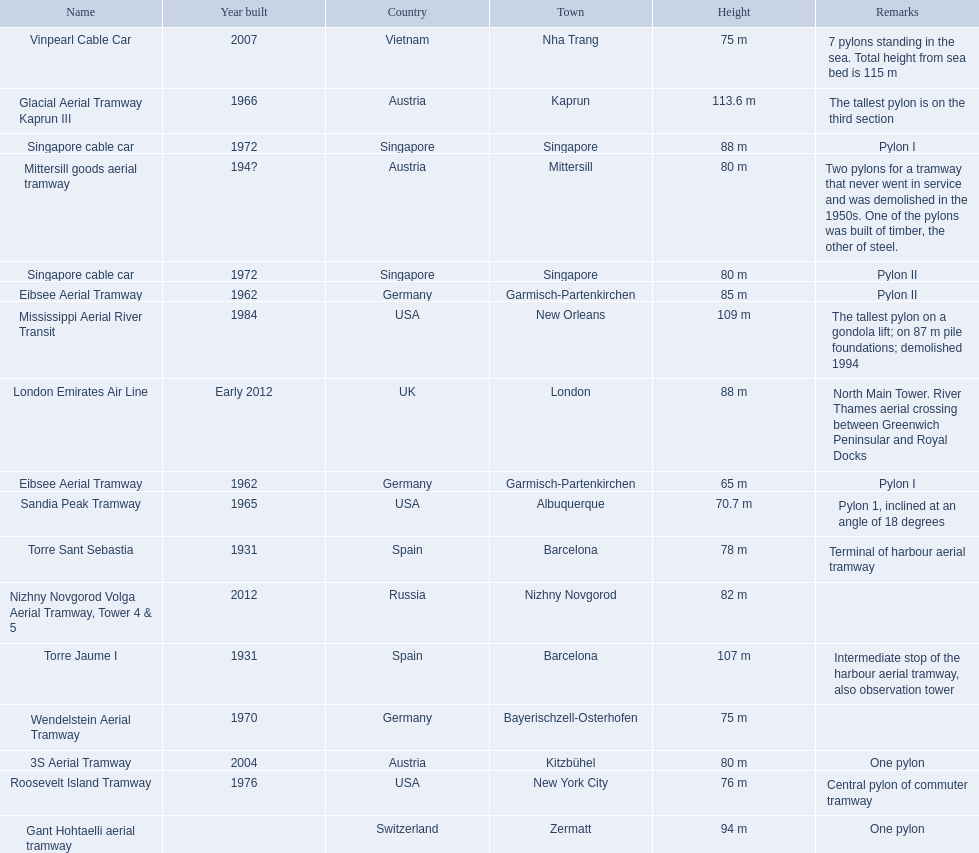Which aerial lifts are over 100 meters tall? Glacial Aerial Tramway Kaprun III, Mississippi Aerial River Transit, Torre Jaume I. Which of those was built last? Mississippi Aerial River Transit. And what is its total height? 109 m. Which lift has the second highest height? Mississippi Aerial River Transit. Can you give me this table as a dict? {'header': ['Name', 'Year built', 'Country', 'Town', 'Height', 'Remarks'], 'rows': [['Vinpearl Cable Car', '2007', 'Vietnam', 'Nha Trang', '75 m', '7 pylons standing in the sea. Total height from sea bed is 115 m'], ['Glacial Aerial Tramway Kaprun III', '1966', 'Austria', 'Kaprun', '113.6 m', 'The tallest pylon is on the third section'], ['Singapore cable car', '1972', 'Singapore', 'Singapore', '88 m', 'Pylon I'], ['Mittersill goods aerial tramway', '194?', 'Austria', 'Mittersill', '80 m', 'Two pylons for a tramway that never went in service and was demolished in the 1950s. One of the pylons was built of timber, the other of steel.'], ['Singapore cable car', '1972', 'Singapore', 'Singapore', '80 m', 'Pylon II'], ['Eibsee Aerial Tramway', '1962', 'Germany', 'Garmisch-Partenkirchen', '85 m', 'Pylon II'], ['Mississippi Aerial River Transit', '1984', 'USA', 'New Orleans', '109 m', 'The tallest pylon on a gondola lift; on 87 m pile foundations; demolished 1994'], ['London Emirates Air Line', 'Early 2012', 'UK', 'London', '88 m', 'North Main Tower. River Thames aerial crossing between Greenwich Peninsular and Royal Docks'], ['Eibsee Aerial Tramway', '1962', 'Germany', 'Garmisch-Partenkirchen', '65 m', 'Pylon I'], ['Sandia Peak Tramway', '1965', 'USA', 'Albuquerque', '70.7 m', 'Pylon 1, inclined at an angle of 18 degrees'], ['Torre Sant Sebastia', '1931', 'Spain', 'Barcelona', '78 m', 'Terminal of harbour aerial tramway'], ['Nizhny Novgorod Volga Aerial Tramway, Tower 4 & 5', '2012', 'Russia', 'Nizhny Novgorod', '82 m', ''], ['Torre Jaume I', '1931', 'Spain', 'Barcelona', '107 m', 'Intermediate stop of the harbour aerial tramway, also observation tower'], ['Wendelstein Aerial Tramway', '1970', 'Germany', 'Bayerischzell-Osterhofen', '75 m', ''], ['3S Aerial Tramway', '2004', 'Austria', 'Kitzbühel', '80 m', 'One pylon'], ['Roosevelt Island Tramway', '1976', 'USA', 'New York City', '76 m', 'Central pylon of commuter tramway'], ['Gant Hohtaelli aerial tramway', '', 'Switzerland', 'Zermatt', '94 m', 'One pylon']]} What is the value of the height? 109 m. 